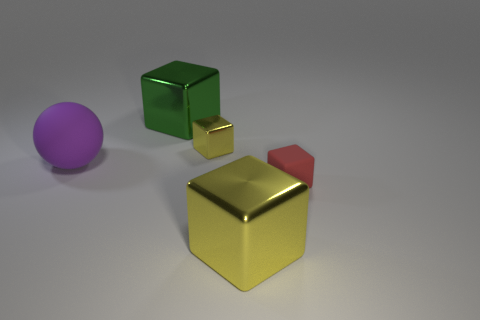There is a object in front of the red block; what is its color?
Provide a succinct answer. Yellow. What number of big objects are either red metallic blocks or shiny cubes?
Provide a short and direct response. 2. Do the thing in front of the red block and the small block that is behind the tiny red rubber thing have the same color?
Your answer should be compact. Yes. How many other objects are the same color as the tiny metallic cube?
Your answer should be compact. 1. What number of red objects are big matte blocks or small rubber cubes?
Your answer should be compact. 1. Do the tiny metal object and the large object on the right side of the large green object have the same shape?
Offer a very short reply. Yes. What is the shape of the small red thing?
Your answer should be very brief. Cube. What is the material of the green object that is the same size as the purple object?
Ensure brevity in your answer.  Metal. Are there any other things that have the same size as the ball?
Offer a very short reply. Yes. What number of objects are brown rubber blocks or large blocks in front of the rubber cube?
Your response must be concise. 1. 